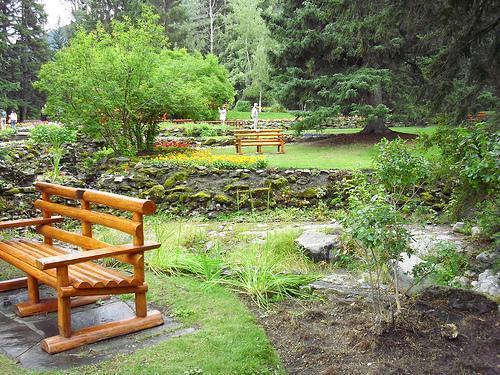How many people are wearing white?
Give a very brief answer. 3. How many benches?
Give a very brief answer. 2. 